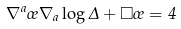Convert formula to latex. <formula><loc_0><loc_0><loc_500><loc_500>\nabla ^ { a } \sigma \nabla _ { a } \log \Delta + \Box \sigma = 4</formula> 